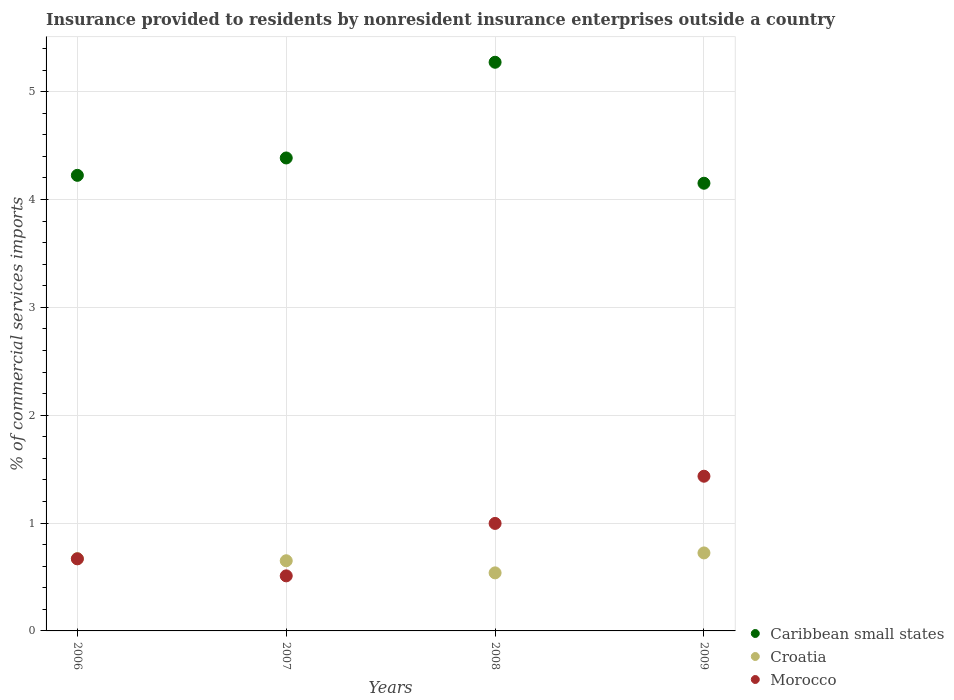Is the number of dotlines equal to the number of legend labels?
Give a very brief answer. Yes. What is the Insurance provided to residents in Croatia in 2006?
Your answer should be very brief. 0.67. Across all years, what is the maximum Insurance provided to residents in Caribbean small states?
Your answer should be very brief. 5.27. Across all years, what is the minimum Insurance provided to residents in Croatia?
Provide a succinct answer. 0.54. In which year was the Insurance provided to residents in Croatia maximum?
Offer a terse response. 2009. What is the total Insurance provided to residents in Croatia in the graph?
Your answer should be very brief. 2.58. What is the difference between the Insurance provided to residents in Croatia in 2007 and that in 2009?
Keep it short and to the point. -0.07. What is the difference between the Insurance provided to residents in Croatia in 2006 and the Insurance provided to residents in Morocco in 2009?
Your answer should be very brief. -0.76. What is the average Insurance provided to residents in Croatia per year?
Provide a succinct answer. 0.65. In the year 2006, what is the difference between the Insurance provided to residents in Caribbean small states and Insurance provided to residents in Morocco?
Offer a very short reply. 3.56. In how many years, is the Insurance provided to residents in Morocco greater than 1.4 %?
Your answer should be very brief. 1. What is the ratio of the Insurance provided to residents in Croatia in 2006 to that in 2008?
Your response must be concise. 1.25. Is the Insurance provided to residents in Caribbean small states in 2006 less than that in 2008?
Give a very brief answer. Yes. What is the difference between the highest and the second highest Insurance provided to residents in Croatia?
Your answer should be very brief. 0.05. What is the difference between the highest and the lowest Insurance provided to residents in Caribbean small states?
Keep it short and to the point. 1.12. Is the Insurance provided to residents in Morocco strictly greater than the Insurance provided to residents in Croatia over the years?
Provide a short and direct response. No. Are the values on the major ticks of Y-axis written in scientific E-notation?
Provide a succinct answer. No. Does the graph contain grids?
Your response must be concise. Yes. What is the title of the graph?
Offer a very short reply. Insurance provided to residents by nonresident insurance enterprises outside a country. What is the label or title of the Y-axis?
Make the answer very short. % of commercial services imports. What is the % of commercial services imports of Caribbean small states in 2006?
Offer a very short reply. 4.22. What is the % of commercial services imports in Croatia in 2006?
Offer a very short reply. 0.67. What is the % of commercial services imports in Morocco in 2006?
Provide a succinct answer. 0.67. What is the % of commercial services imports in Caribbean small states in 2007?
Your answer should be very brief. 4.38. What is the % of commercial services imports of Croatia in 2007?
Your answer should be compact. 0.65. What is the % of commercial services imports in Morocco in 2007?
Your answer should be compact. 0.51. What is the % of commercial services imports in Caribbean small states in 2008?
Your answer should be compact. 5.27. What is the % of commercial services imports in Croatia in 2008?
Offer a terse response. 0.54. What is the % of commercial services imports of Morocco in 2008?
Your answer should be very brief. 1. What is the % of commercial services imports of Caribbean small states in 2009?
Give a very brief answer. 4.15. What is the % of commercial services imports in Croatia in 2009?
Your answer should be compact. 0.72. What is the % of commercial services imports in Morocco in 2009?
Your answer should be compact. 1.43. Across all years, what is the maximum % of commercial services imports of Caribbean small states?
Make the answer very short. 5.27. Across all years, what is the maximum % of commercial services imports in Croatia?
Provide a succinct answer. 0.72. Across all years, what is the maximum % of commercial services imports of Morocco?
Make the answer very short. 1.43. Across all years, what is the minimum % of commercial services imports of Caribbean small states?
Ensure brevity in your answer.  4.15. Across all years, what is the minimum % of commercial services imports in Croatia?
Provide a succinct answer. 0.54. Across all years, what is the minimum % of commercial services imports in Morocco?
Give a very brief answer. 0.51. What is the total % of commercial services imports of Caribbean small states in the graph?
Your answer should be very brief. 18.03. What is the total % of commercial services imports in Croatia in the graph?
Make the answer very short. 2.58. What is the total % of commercial services imports in Morocco in the graph?
Offer a very short reply. 3.61. What is the difference between the % of commercial services imports of Caribbean small states in 2006 and that in 2007?
Your answer should be very brief. -0.16. What is the difference between the % of commercial services imports in Croatia in 2006 and that in 2007?
Your answer should be very brief. 0.02. What is the difference between the % of commercial services imports of Morocco in 2006 and that in 2007?
Give a very brief answer. 0.16. What is the difference between the % of commercial services imports in Caribbean small states in 2006 and that in 2008?
Provide a short and direct response. -1.05. What is the difference between the % of commercial services imports of Croatia in 2006 and that in 2008?
Offer a terse response. 0.13. What is the difference between the % of commercial services imports of Morocco in 2006 and that in 2008?
Keep it short and to the point. -0.33. What is the difference between the % of commercial services imports in Caribbean small states in 2006 and that in 2009?
Keep it short and to the point. 0.07. What is the difference between the % of commercial services imports in Croatia in 2006 and that in 2009?
Your response must be concise. -0.05. What is the difference between the % of commercial services imports of Morocco in 2006 and that in 2009?
Offer a terse response. -0.77. What is the difference between the % of commercial services imports in Caribbean small states in 2007 and that in 2008?
Offer a very short reply. -0.89. What is the difference between the % of commercial services imports of Croatia in 2007 and that in 2008?
Give a very brief answer. 0.11. What is the difference between the % of commercial services imports in Morocco in 2007 and that in 2008?
Make the answer very short. -0.49. What is the difference between the % of commercial services imports in Caribbean small states in 2007 and that in 2009?
Give a very brief answer. 0.23. What is the difference between the % of commercial services imports in Croatia in 2007 and that in 2009?
Provide a short and direct response. -0.07. What is the difference between the % of commercial services imports of Morocco in 2007 and that in 2009?
Ensure brevity in your answer.  -0.92. What is the difference between the % of commercial services imports of Caribbean small states in 2008 and that in 2009?
Provide a succinct answer. 1.12. What is the difference between the % of commercial services imports of Croatia in 2008 and that in 2009?
Ensure brevity in your answer.  -0.18. What is the difference between the % of commercial services imports in Morocco in 2008 and that in 2009?
Offer a very short reply. -0.44. What is the difference between the % of commercial services imports of Caribbean small states in 2006 and the % of commercial services imports of Croatia in 2007?
Your answer should be compact. 3.57. What is the difference between the % of commercial services imports of Caribbean small states in 2006 and the % of commercial services imports of Morocco in 2007?
Provide a short and direct response. 3.71. What is the difference between the % of commercial services imports in Croatia in 2006 and the % of commercial services imports in Morocco in 2007?
Your answer should be very brief. 0.16. What is the difference between the % of commercial services imports of Caribbean small states in 2006 and the % of commercial services imports of Croatia in 2008?
Make the answer very short. 3.69. What is the difference between the % of commercial services imports of Caribbean small states in 2006 and the % of commercial services imports of Morocco in 2008?
Make the answer very short. 3.23. What is the difference between the % of commercial services imports in Croatia in 2006 and the % of commercial services imports in Morocco in 2008?
Keep it short and to the point. -0.33. What is the difference between the % of commercial services imports in Caribbean small states in 2006 and the % of commercial services imports in Croatia in 2009?
Ensure brevity in your answer.  3.5. What is the difference between the % of commercial services imports in Caribbean small states in 2006 and the % of commercial services imports in Morocco in 2009?
Provide a succinct answer. 2.79. What is the difference between the % of commercial services imports of Croatia in 2006 and the % of commercial services imports of Morocco in 2009?
Offer a very short reply. -0.76. What is the difference between the % of commercial services imports in Caribbean small states in 2007 and the % of commercial services imports in Croatia in 2008?
Your answer should be very brief. 3.85. What is the difference between the % of commercial services imports in Caribbean small states in 2007 and the % of commercial services imports in Morocco in 2008?
Your answer should be compact. 3.39. What is the difference between the % of commercial services imports in Croatia in 2007 and the % of commercial services imports in Morocco in 2008?
Your response must be concise. -0.35. What is the difference between the % of commercial services imports in Caribbean small states in 2007 and the % of commercial services imports in Croatia in 2009?
Offer a terse response. 3.66. What is the difference between the % of commercial services imports of Caribbean small states in 2007 and the % of commercial services imports of Morocco in 2009?
Your answer should be very brief. 2.95. What is the difference between the % of commercial services imports of Croatia in 2007 and the % of commercial services imports of Morocco in 2009?
Your response must be concise. -0.78. What is the difference between the % of commercial services imports in Caribbean small states in 2008 and the % of commercial services imports in Croatia in 2009?
Keep it short and to the point. 4.55. What is the difference between the % of commercial services imports of Caribbean small states in 2008 and the % of commercial services imports of Morocco in 2009?
Make the answer very short. 3.84. What is the difference between the % of commercial services imports in Croatia in 2008 and the % of commercial services imports in Morocco in 2009?
Give a very brief answer. -0.9. What is the average % of commercial services imports of Caribbean small states per year?
Offer a very short reply. 4.51. What is the average % of commercial services imports in Croatia per year?
Your answer should be very brief. 0.65. What is the average % of commercial services imports in Morocco per year?
Your answer should be very brief. 0.9. In the year 2006, what is the difference between the % of commercial services imports of Caribbean small states and % of commercial services imports of Croatia?
Make the answer very short. 3.55. In the year 2006, what is the difference between the % of commercial services imports of Caribbean small states and % of commercial services imports of Morocco?
Keep it short and to the point. 3.56. In the year 2006, what is the difference between the % of commercial services imports in Croatia and % of commercial services imports in Morocco?
Offer a terse response. 0. In the year 2007, what is the difference between the % of commercial services imports of Caribbean small states and % of commercial services imports of Croatia?
Give a very brief answer. 3.73. In the year 2007, what is the difference between the % of commercial services imports of Caribbean small states and % of commercial services imports of Morocco?
Keep it short and to the point. 3.87. In the year 2007, what is the difference between the % of commercial services imports in Croatia and % of commercial services imports in Morocco?
Make the answer very short. 0.14. In the year 2008, what is the difference between the % of commercial services imports in Caribbean small states and % of commercial services imports in Croatia?
Your response must be concise. 4.73. In the year 2008, what is the difference between the % of commercial services imports of Caribbean small states and % of commercial services imports of Morocco?
Make the answer very short. 4.28. In the year 2008, what is the difference between the % of commercial services imports in Croatia and % of commercial services imports in Morocco?
Your answer should be compact. -0.46. In the year 2009, what is the difference between the % of commercial services imports in Caribbean small states and % of commercial services imports in Croatia?
Make the answer very short. 3.43. In the year 2009, what is the difference between the % of commercial services imports of Caribbean small states and % of commercial services imports of Morocco?
Keep it short and to the point. 2.72. In the year 2009, what is the difference between the % of commercial services imports of Croatia and % of commercial services imports of Morocco?
Your answer should be compact. -0.71. What is the ratio of the % of commercial services imports of Caribbean small states in 2006 to that in 2007?
Provide a short and direct response. 0.96. What is the ratio of the % of commercial services imports of Croatia in 2006 to that in 2007?
Your response must be concise. 1.03. What is the ratio of the % of commercial services imports in Morocco in 2006 to that in 2007?
Keep it short and to the point. 1.31. What is the ratio of the % of commercial services imports in Caribbean small states in 2006 to that in 2008?
Keep it short and to the point. 0.8. What is the ratio of the % of commercial services imports of Croatia in 2006 to that in 2008?
Offer a terse response. 1.25. What is the ratio of the % of commercial services imports in Morocco in 2006 to that in 2008?
Offer a terse response. 0.67. What is the ratio of the % of commercial services imports in Caribbean small states in 2006 to that in 2009?
Give a very brief answer. 1.02. What is the ratio of the % of commercial services imports of Croatia in 2006 to that in 2009?
Provide a succinct answer. 0.93. What is the ratio of the % of commercial services imports in Morocco in 2006 to that in 2009?
Your answer should be compact. 0.47. What is the ratio of the % of commercial services imports of Caribbean small states in 2007 to that in 2008?
Provide a succinct answer. 0.83. What is the ratio of the % of commercial services imports of Croatia in 2007 to that in 2008?
Offer a terse response. 1.21. What is the ratio of the % of commercial services imports of Morocco in 2007 to that in 2008?
Keep it short and to the point. 0.51. What is the ratio of the % of commercial services imports in Caribbean small states in 2007 to that in 2009?
Keep it short and to the point. 1.06. What is the ratio of the % of commercial services imports in Croatia in 2007 to that in 2009?
Your answer should be compact. 0.9. What is the ratio of the % of commercial services imports of Morocco in 2007 to that in 2009?
Keep it short and to the point. 0.36. What is the ratio of the % of commercial services imports of Caribbean small states in 2008 to that in 2009?
Your answer should be very brief. 1.27. What is the ratio of the % of commercial services imports in Croatia in 2008 to that in 2009?
Ensure brevity in your answer.  0.74. What is the ratio of the % of commercial services imports in Morocco in 2008 to that in 2009?
Your answer should be very brief. 0.69. What is the difference between the highest and the second highest % of commercial services imports of Caribbean small states?
Your response must be concise. 0.89. What is the difference between the highest and the second highest % of commercial services imports in Croatia?
Provide a succinct answer. 0.05. What is the difference between the highest and the second highest % of commercial services imports of Morocco?
Provide a succinct answer. 0.44. What is the difference between the highest and the lowest % of commercial services imports of Caribbean small states?
Make the answer very short. 1.12. What is the difference between the highest and the lowest % of commercial services imports in Croatia?
Keep it short and to the point. 0.18. What is the difference between the highest and the lowest % of commercial services imports in Morocco?
Offer a terse response. 0.92. 